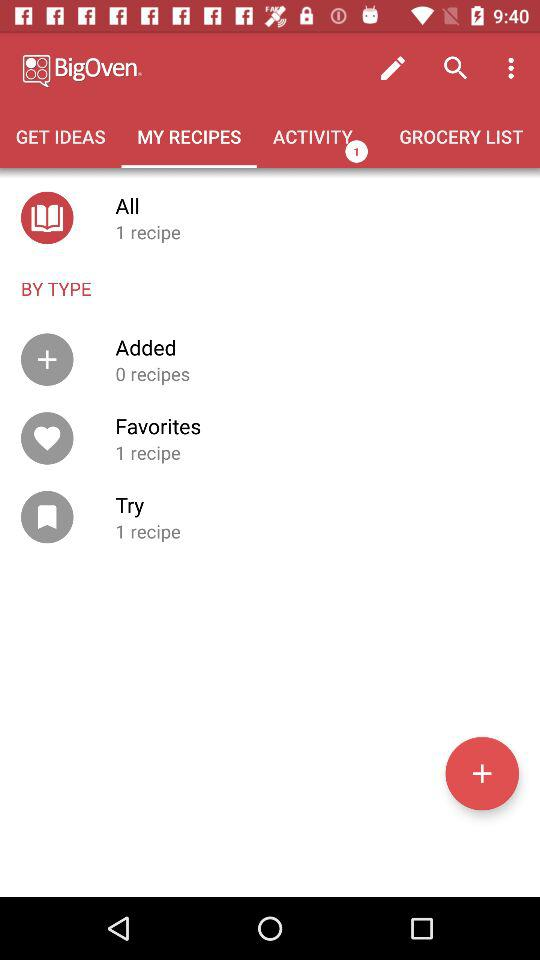How many more recipes are in Favorites than Added?
Answer the question using a single word or phrase. 1 